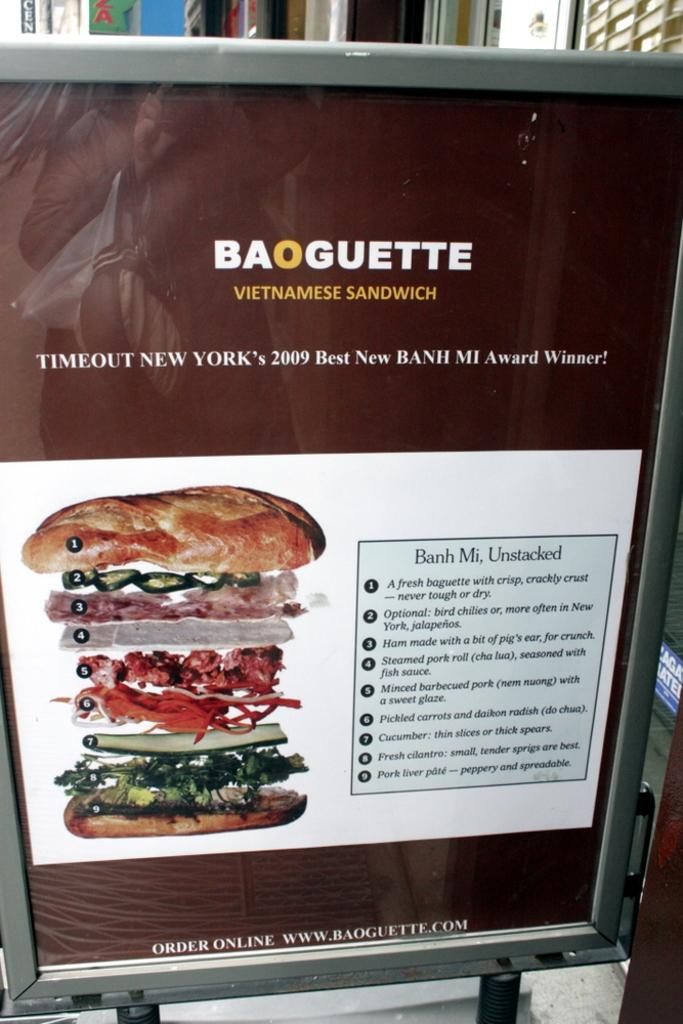What is on the board in the image? There is a poster on the board in the image. What can be seen on the poster? There is writing on the poster. What type of food item is visible in the image? There is a food item in the image. How many girls are playing the current in the image? There are no girls or musical instruments present in the image, so it is not possible to answer that question. 